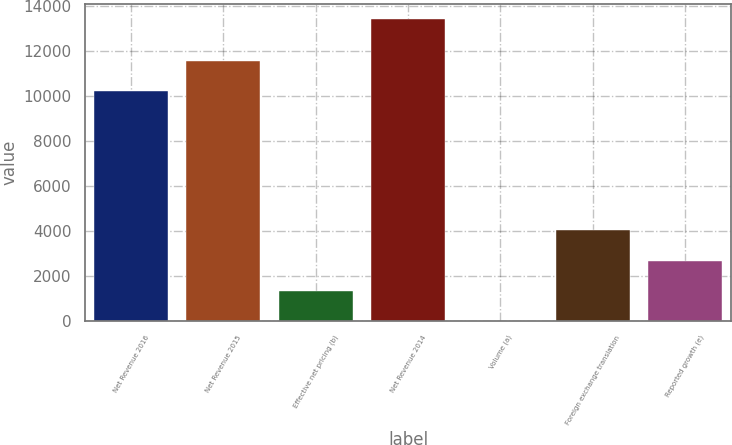<chart> <loc_0><loc_0><loc_500><loc_500><bar_chart><fcel>Net Revenue 2016<fcel>Net Revenue 2015<fcel>Effective net pricing (b)<fcel>Net Revenue 2014<fcel>Volume (a)<fcel>Foreign exchange translation<fcel>Reported growth (e)<nl><fcel>10216<fcel>11555.7<fcel>1341.7<fcel>13399<fcel>2<fcel>4021.1<fcel>2681.4<nl></chart> 